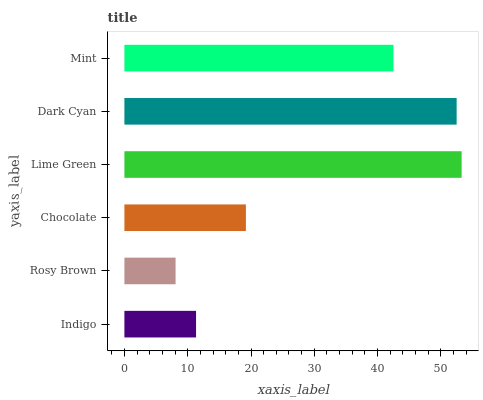Is Rosy Brown the minimum?
Answer yes or no. Yes. Is Lime Green the maximum?
Answer yes or no. Yes. Is Chocolate the minimum?
Answer yes or no. No. Is Chocolate the maximum?
Answer yes or no. No. Is Chocolate greater than Rosy Brown?
Answer yes or no. Yes. Is Rosy Brown less than Chocolate?
Answer yes or no. Yes. Is Rosy Brown greater than Chocolate?
Answer yes or no. No. Is Chocolate less than Rosy Brown?
Answer yes or no. No. Is Mint the high median?
Answer yes or no. Yes. Is Chocolate the low median?
Answer yes or no. Yes. Is Indigo the high median?
Answer yes or no. No. Is Rosy Brown the low median?
Answer yes or no. No. 